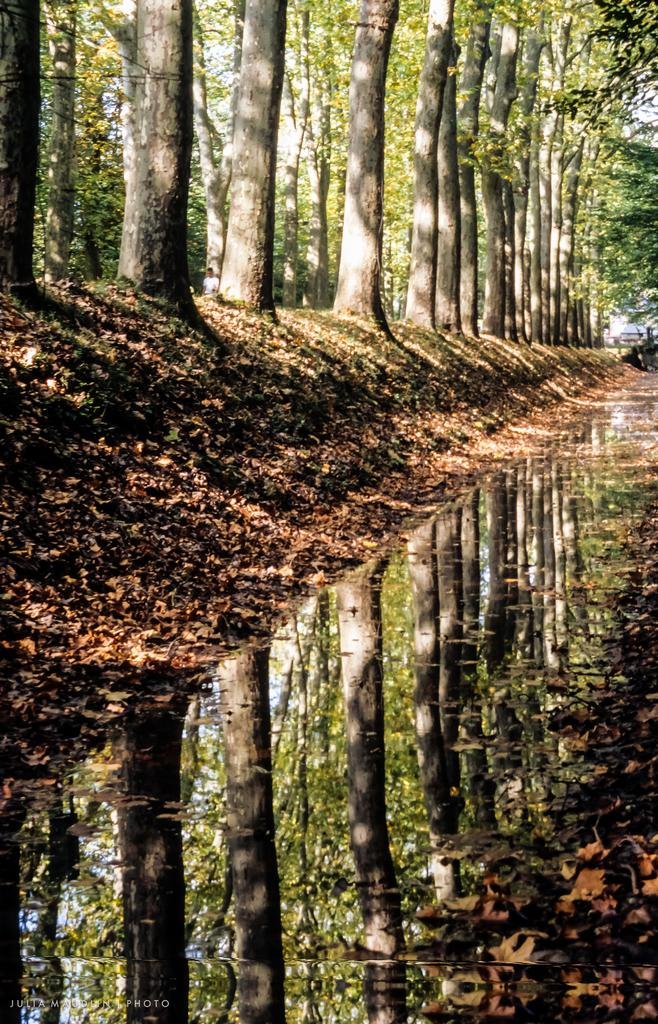What type of water feature is in the image? There is a small canal in the image. What can be seen on the left side of the canal? Trees are present on the left side of the canal. How would you describe the land around the canal? The land around the canal is covered with dry leaves. Reasoning: Let'g: Let's think step by step in order to produce the conversation. We start by identifying the main water feature in the image, which is the small canal. Then, we describe the vegetation and landscape surrounding the canal, focusing on the trees on the left side and the dry leaves covering the land. Each question is designed to elicit a specific detail about the image that is known from the provided facts. Absurd Question/Answer: What type of whip can be seen being used to sort the leaves in the image? There is no whip or leaf-sorting activity present in the image. 